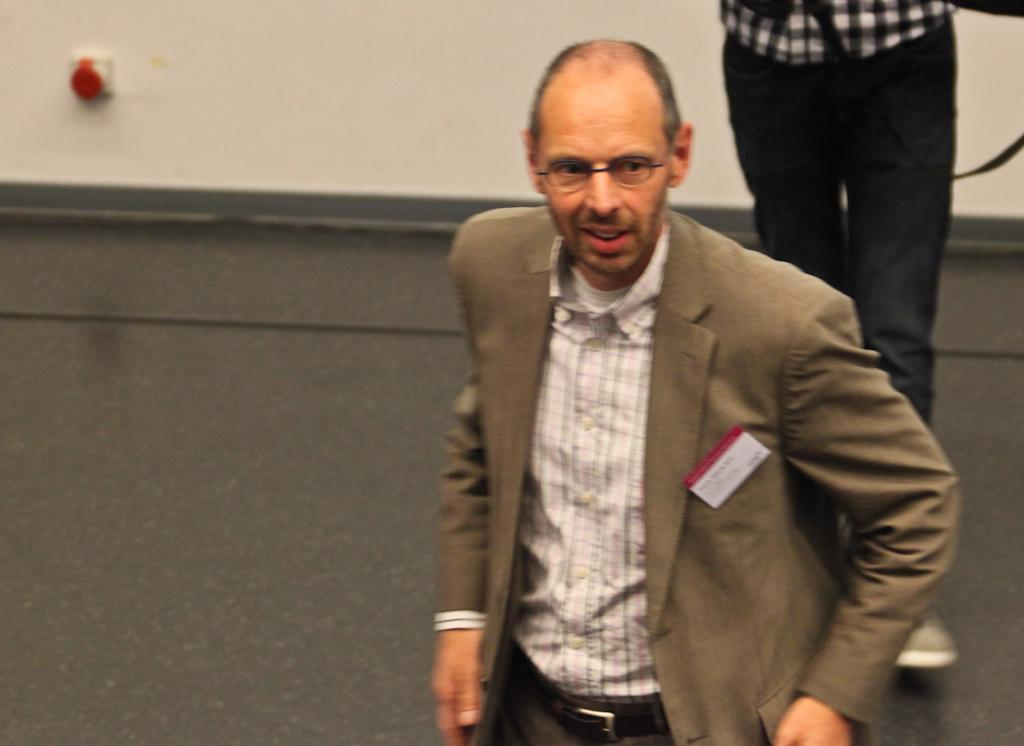What is the person in the image wearing? There is a person wearing a blazer in the image. What is the person in the image doing? There is a person walking on the floor in the image. What can be seen in the background of the image? There is a wall in the background of the image. What type of wilderness can be seen in the image? There is no wilderness present in the image; it features a person walking on the floor with a wall in the background. 